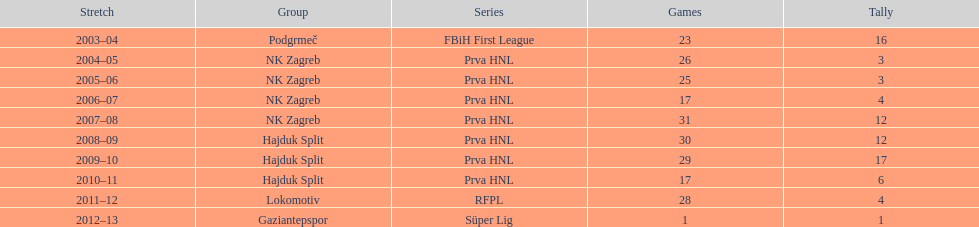After scoring against bulgaria in zenica, ibricic also scored against this team in a 7-0 victory in zenica less then a month after the friendly match against bulgaria. Estonia. Give me the full table as a dictionary. {'header': ['Stretch', 'Group', 'Series', 'Games', 'Tally'], 'rows': [['2003–04', 'Podgrmeč', 'FBiH First League', '23', '16'], ['2004–05', 'NK Zagreb', 'Prva HNL', '26', '3'], ['2005–06', 'NK Zagreb', 'Prva HNL', '25', '3'], ['2006–07', 'NK Zagreb', 'Prva HNL', '17', '4'], ['2007–08', 'NK Zagreb', 'Prva HNL', '31', '12'], ['2008–09', 'Hajduk Split', 'Prva HNL', '30', '12'], ['2009–10', 'Hajduk Split', 'Prva HNL', '29', '17'], ['2010–11', 'Hajduk Split', 'Prva HNL', '17', '6'], ['2011–12', 'Lokomotiv', 'RFPL', '28', '4'], ['2012–13', 'Gaziantepspor', 'Süper Lig', '1', '1']]} 